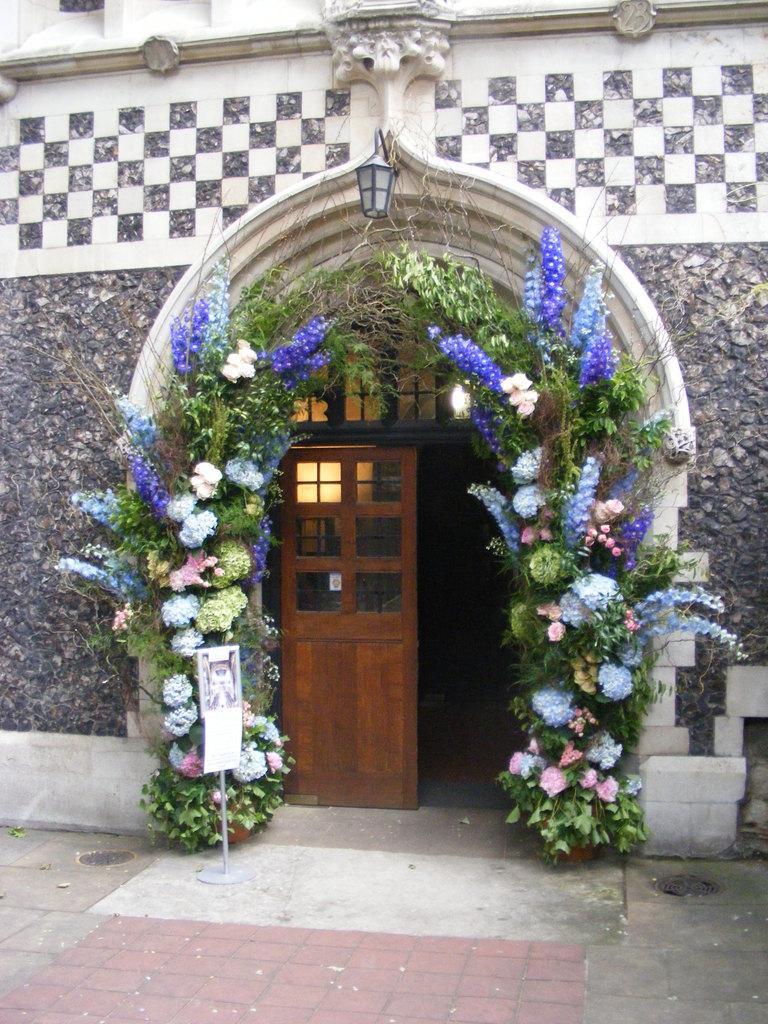How would you summarize this image in a sentence or two? In this image I see a building over here and I see the door over here and I see the path and I see the decoration with leaves and flowers. 